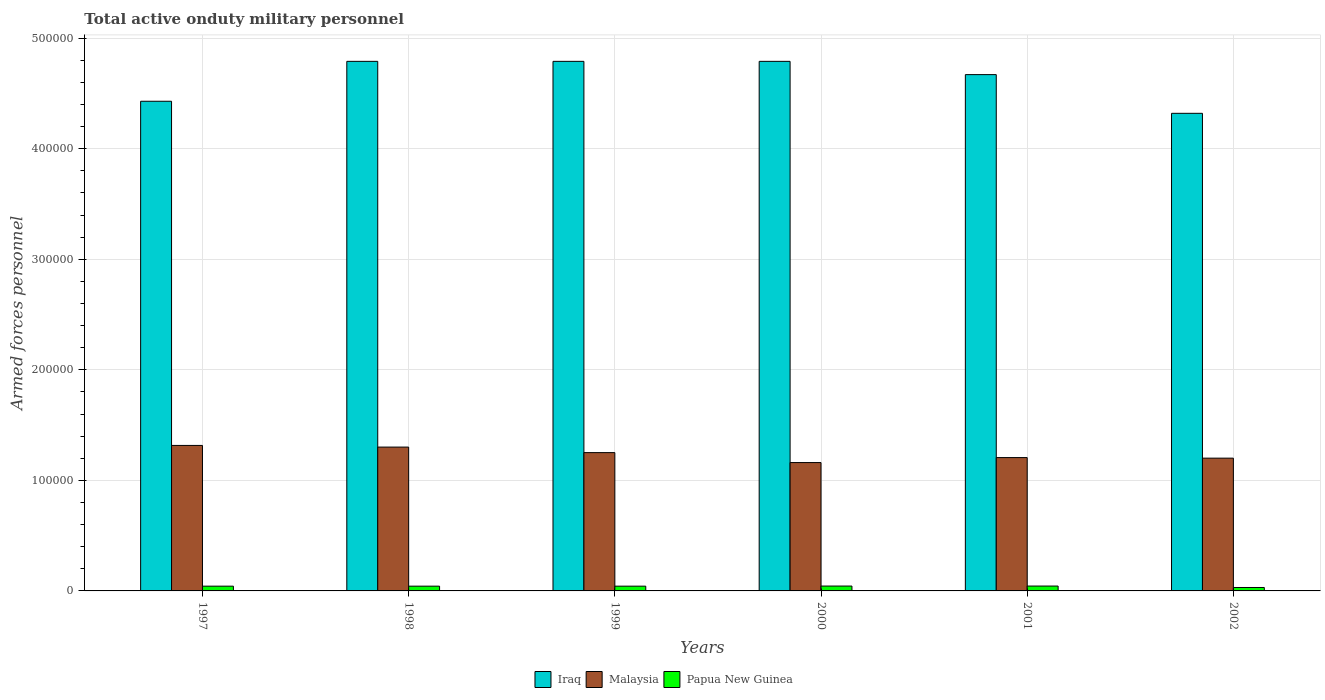How many different coloured bars are there?
Give a very brief answer. 3. Are the number of bars per tick equal to the number of legend labels?
Offer a very short reply. Yes. How many bars are there on the 6th tick from the right?
Offer a terse response. 3. What is the number of armed forces personnel in Papua New Guinea in 2002?
Give a very brief answer. 3100. Across all years, what is the maximum number of armed forces personnel in Papua New Guinea?
Your answer should be very brief. 4400. Across all years, what is the minimum number of armed forces personnel in Papua New Guinea?
Your response must be concise. 3100. What is the total number of armed forces personnel in Papua New Guinea in the graph?
Offer a very short reply. 2.48e+04. What is the difference between the number of armed forces personnel in Malaysia in 2001 and that in 2002?
Keep it short and to the point. 500. What is the difference between the number of armed forces personnel in Iraq in 2000 and the number of armed forces personnel in Papua New Guinea in 1997?
Your answer should be very brief. 4.75e+05. What is the average number of armed forces personnel in Malaysia per year?
Ensure brevity in your answer.  1.24e+05. In the year 1999, what is the difference between the number of armed forces personnel in Malaysia and number of armed forces personnel in Iraq?
Make the answer very short. -3.54e+05. In how many years, is the number of armed forces personnel in Papua New Guinea greater than 40000?
Provide a succinct answer. 0. What is the ratio of the number of armed forces personnel in Iraq in 2001 to that in 2002?
Ensure brevity in your answer.  1.08. Is the number of armed forces personnel in Iraq in 1997 less than that in 1998?
Ensure brevity in your answer.  Yes. What is the difference between the highest and the second highest number of armed forces personnel in Iraq?
Offer a terse response. 0. What is the difference between the highest and the lowest number of armed forces personnel in Papua New Guinea?
Provide a succinct answer. 1300. Is the sum of the number of armed forces personnel in Papua New Guinea in 2000 and 2002 greater than the maximum number of armed forces personnel in Iraq across all years?
Your answer should be compact. No. What does the 1st bar from the left in 1997 represents?
Provide a short and direct response. Iraq. What does the 1st bar from the right in 1997 represents?
Give a very brief answer. Papua New Guinea. Is it the case that in every year, the sum of the number of armed forces personnel in Iraq and number of armed forces personnel in Malaysia is greater than the number of armed forces personnel in Papua New Guinea?
Your answer should be very brief. Yes. How many bars are there?
Keep it short and to the point. 18. Are all the bars in the graph horizontal?
Your response must be concise. No. Where does the legend appear in the graph?
Offer a very short reply. Bottom center. How many legend labels are there?
Your response must be concise. 3. How are the legend labels stacked?
Ensure brevity in your answer.  Horizontal. What is the title of the graph?
Offer a terse response. Total active onduty military personnel. What is the label or title of the X-axis?
Provide a succinct answer. Years. What is the label or title of the Y-axis?
Make the answer very short. Armed forces personnel. What is the Armed forces personnel in Iraq in 1997?
Make the answer very short. 4.43e+05. What is the Armed forces personnel in Malaysia in 1997?
Your answer should be very brief. 1.32e+05. What is the Armed forces personnel of Papua New Guinea in 1997?
Ensure brevity in your answer.  4300. What is the Armed forces personnel in Iraq in 1998?
Make the answer very short. 4.79e+05. What is the Armed forces personnel in Malaysia in 1998?
Your answer should be very brief. 1.30e+05. What is the Armed forces personnel of Papua New Guinea in 1998?
Your response must be concise. 4300. What is the Armed forces personnel in Iraq in 1999?
Your answer should be compact. 4.79e+05. What is the Armed forces personnel in Malaysia in 1999?
Your answer should be very brief. 1.25e+05. What is the Armed forces personnel in Papua New Guinea in 1999?
Give a very brief answer. 4300. What is the Armed forces personnel in Iraq in 2000?
Offer a very short reply. 4.79e+05. What is the Armed forces personnel in Malaysia in 2000?
Keep it short and to the point. 1.16e+05. What is the Armed forces personnel of Papua New Guinea in 2000?
Offer a very short reply. 4400. What is the Armed forces personnel of Iraq in 2001?
Your response must be concise. 4.67e+05. What is the Armed forces personnel in Malaysia in 2001?
Provide a succinct answer. 1.21e+05. What is the Armed forces personnel of Papua New Guinea in 2001?
Ensure brevity in your answer.  4400. What is the Armed forces personnel in Iraq in 2002?
Keep it short and to the point. 4.32e+05. What is the Armed forces personnel of Malaysia in 2002?
Provide a succinct answer. 1.20e+05. What is the Armed forces personnel of Papua New Guinea in 2002?
Offer a very short reply. 3100. Across all years, what is the maximum Armed forces personnel of Iraq?
Your response must be concise. 4.79e+05. Across all years, what is the maximum Armed forces personnel of Malaysia?
Offer a terse response. 1.32e+05. Across all years, what is the maximum Armed forces personnel in Papua New Guinea?
Your answer should be very brief. 4400. Across all years, what is the minimum Armed forces personnel in Iraq?
Your response must be concise. 4.32e+05. Across all years, what is the minimum Armed forces personnel of Malaysia?
Ensure brevity in your answer.  1.16e+05. Across all years, what is the minimum Armed forces personnel in Papua New Guinea?
Offer a very short reply. 3100. What is the total Armed forces personnel of Iraq in the graph?
Your answer should be very brief. 2.78e+06. What is the total Armed forces personnel in Malaysia in the graph?
Your answer should be very brief. 7.44e+05. What is the total Armed forces personnel in Papua New Guinea in the graph?
Make the answer very short. 2.48e+04. What is the difference between the Armed forces personnel in Iraq in 1997 and that in 1998?
Give a very brief answer. -3.61e+04. What is the difference between the Armed forces personnel in Malaysia in 1997 and that in 1998?
Offer a very short reply. 1500. What is the difference between the Armed forces personnel of Papua New Guinea in 1997 and that in 1998?
Ensure brevity in your answer.  0. What is the difference between the Armed forces personnel of Iraq in 1997 and that in 1999?
Ensure brevity in your answer.  -3.61e+04. What is the difference between the Armed forces personnel in Malaysia in 1997 and that in 1999?
Give a very brief answer. 6500. What is the difference between the Armed forces personnel in Papua New Guinea in 1997 and that in 1999?
Provide a succinct answer. 0. What is the difference between the Armed forces personnel of Iraq in 1997 and that in 2000?
Your response must be concise. -3.61e+04. What is the difference between the Armed forces personnel of Malaysia in 1997 and that in 2000?
Give a very brief answer. 1.55e+04. What is the difference between the Armed forces personnel in Papua New Guinea in 1997 and that in 2000?
Your answer should be very brief. -100. What is the difference between the Armed forces personnel of Iraq in 1997 and that in 2001?
Provide a succinct answer. -2.41e+04. What is the difference between the Armed forces personnel of Malaysia in 1997 and that in 2001?
Your answer should be compact. 1.10e+04. What is the difference between the Armed forces personnel of Papua New Guinea in 1997 and that in 2001?
Your answer should be very brief. -100. What is the difference between the Armed forces personnel of Iraq in 1997 and that in 2002?
Your answer should be very brief. 1.09e+04. What is the difference between the Armed forces personnel in Malaysia in 1997 and that in 2002?
Offer a terse response. 1.15e+04. What is the difference between the Armed forces personnel in Papua New Guinea in 1997 and that in 2002?
Keep it short and to the point. 1200. What is the difference between the Armed forces personnel of Malaysia in 1998 and that in 1999?
Your answer should be compact. 5000. What is the difference between the Armed forces personnel in Papua New Guinea in 1998 and that in 1999?
Make the answer very short. 0. What is the difference between the Armed forces personnel of Iraq in 1998 and that in 2000?
Provide a succinct answer. 0. What is the difference between the Armed forces personnel in Malaysia in 1998 and that in 2000?
Give a very brief answer. 1.40e+04. What is the difference between the Armed forces personnel of Papua New Guinea in 1998 and that in 2000?
Make the answer very short. -100. What is the difference between the Armed forces personnel in Iraq in 1998 and that in 2001?
Provide a short and direct response. 1.20e+04. What is the difference between the Armed forces personnel of Malaysia in 1998 and that in 2001?
Your answer should be very brief. 9500. What is the difference between the Armed forces personnel in Papua New Guinea in 1998 and that in 2001?
Provide a succinct answer. -100. What is the difference between the Armed forces personnel in Iraq in 1998 and that in 2002?
Offer a terse response. 4.70e+04. What is the difference between the Armed forces personnel of Malaysia in 1998 and that in 2002?
Give a very brief answer. 10000. What is the difference between the Armed forces personnel of Papua New Guinea in 1998 and that in 2002?
Ensure brevity in your answer.  1200. What is the difference between the Armed forces personnel in Malaysia in 1999 and that in 2000?
Make the answer very short. 9000. What is the difference between the Armed forces personnel of Papua New Guinea in 1999 and that in 2000?
Your answer should be compact. -100. What is the difference between the Armed forces personnel in Iraq in 1999 and that in 2001?
Make the answer very short. 1.20e+04. What is the difference between the Armed forces personnel of Malaysia in 1999 and that in 2001?
Offer a very short reply. 4500. What is the difference between the Armed forces personnel of Papua New Guinea in 1999 and that in 2001?
Your answer should be very brief. -100. What is the difference between the Armed forces personnel of Iraq in 1999 and that in 2002?
Offer a terse response. 4.70e+04. What is the difference between the Armed forces personnel in Papua New Guinea in 1999 and that in 2002?
Your answer should be very brief. 1200. What is the difference between the Armed forces personnel of Iraq in 2000 and that in 2001?
Your answer should be compact. 1.20e+04. What is the difference between the Armed forces personnel in Malaysia in 2000 and that in 2001?
Your response must be concise. -4500. What is the difference between the Armed forces personnel in Iraq in 2000 and that in 2002?
Provide a short and direct response. 4.70e+04. What is the difference between the Armed forces personnel of Malaysia in 2000 and that in 2002?
Ensure brevity in your answer.  -4000. What is the difference between the Armed forces personnel in Papua New Guinea in 2000 and that in 2002?
Your response must be concise. 1300. What is the difference between the Armed forces personnel in Iraq in 2001 and that in 2002?
Keep it short and to the point. 3.50e+04. What is the difference between the Armed forces personnel in Malaysia in 2001 and that in 2002?
Your answer should be very brief. 500. What is the difference between the Armed forces personnel of Papua New Guinea in 2001 and that in 2002?
Provide a succinct answer. 1300. What is the difference between the Armed forces personnel in Iraq in 1997 and the Armed forces personnel in Malaysia in 1998?
Ensure brevity in your answer.  3.13e+05. What is the difference between the Armed forces personnel of Iraq in 1997 and the Armed forces personnel of Papua New Guinea in 1998?
Offer a very short reply. 4.39e+05. What is the difference between the Armed forces personnel of Malaysia in 1997 and the Armed forces personnel of Papua New Guinea in 1998?
Your answer should be compact. 1.27e+05. What is the difference between the Armed forces personnel in Iraq in 1997 and the Armed forces personnel in Malaysia in 1999?
Provide a succinct answer. 3.18e+05. What is the difference between the Armed forces personnel of Iraq in 1997 and the Armed forces personnel of Papua New Guinea in 1999?
Give a very brief answer. 4.39e+05. What is the difference between the Armed forces personnel of Malaysia in 1997 and the Armed forces personnel of Papua New Guinea in 1999?
Ensure brevity in your answer.  1.27e+05. What is the difference between the Armed forces personnel of Iraq in 1997 and the Armed forces personnel of Malaysia in 2000?
Give a very brief answer. 3.27e+05. What is the difference between the Armed forces personnel of Iraq in 1997 and the Armed forces personnel of Papua New Guinea in 2000?
Give a very brief answer. 4.38e+05. What is the difference between the Armed forces personnel in Malaysia in 1997 and the Armed forces personnel in Papua New Guinea in 2000?
Provide a short and direct response. 1.27e+05. What is the difference between the Armed forces personnel of Iraq in 1997 and the Armed forces personnel of Malaysia in 2001?
Your response must be concise. 3.22e+05. What is the difference between the Armed forces personnel of Iraq in 1997 and the Armed forces personnel of Papua New Guinea in 2001?
Keep it short and to the point. 4.38e+05. What is the difference between the Armed forces personnel in Malaysia in 1997 and the Armed forces personnel in Papua New Guinea in 2001?
Ensure brevity in your answer.  1.27e+05. What is the difference between the Armed forces personnel in Iraq in 1997 and the Armed forces personnel in Malaysia in 2002?
Ensure brevity in your answer.  3.23e+05. What is the difference between the Armed forces personnel of Iraq in 1997 and the Armed forces personnel of Papua New Guinea in 2002?
Offer a very short reply. 4.40e+05. What is the difference between the Armed forces personnel in Malaysia in 1997 and the Armed forces personnel in Papua New Guinea in 2002?
Provide a succinct answer. 1.28e+05. What is the difference between the Armed forces personnel in Iraq in 1998 and the Armed forces personnel in Malaysia in 1999?
Provide a succinct answer. 3.54e+05. What is the difference between the Armed forces personnel of Iraq in 1998 and the Armed forces personnel of Papua New Guinea in 1999?
Make the answer very short. 4.75e+05. What is the difference between the Armed forces personnel in Malaysia in 1998 and the Armed forces personnel in Papua New Guinea in 1999?
Make the answer very short. 1.26e+05. What is the difference between the Armed forces personnel of Iraq in 1998 and the Armed forces personnel of Malaysia in 2000?
Give a very brief answer. 3.63e+05. What is the difference between the Armed forces personnel of Iraq in 1998 and the Armed forces personnel of Papua New Guinea in 2000?
Ensure brevity in your answer.  4.75e+05. What is the difference between the Armed forces personnel of Malaysia in 1998 and the Armed forces personnel of Papua New Guinea in 2000?
Provide a succinct answer. 1.26e+05. What is the difference between the Armed forces personnel of Iraq in 1998 and the Armed forces personnel of Malaysia in 2001?
Provide a succinct answer. 3.58e+05. What is the difference between the Armed forces personnel of Iraq in 1998 and the Armed forces personnel of Papua New Guinea in 2001?
Provide a short and direct response. 4.75e+05. What is the difference between the Armed forces personnel in Malaysia in 1998 and the Armed forces personnel in Papua New Guinea in 2001?
Give a very brief answer. 1.26e+05. What is the difference between the Armed forces personnel in Iraq in 1998 and the Armed forces personnel in Malaysia in 2002?
Provide a succinct answer. 3.59e+05. What is the difference between the Armed forces personnel in Iraq in 1998 and the Armed forces personnel in Papua New Guinea in 2002?
Your response must be concise. 4.76e+05. What is the difference between the Armed forces personnel of Malaysia in 1998 and the Armed forces personnel of Papua New Guinea in 2002?
Provide a succinct answer. 1.27e+05. What is the difference between the Armed forces personnel in Iraq in 1999 and the Armed forces personnel in Malaysia in 2000?
Offer a terse response. 3.63e+05. What is the difference between the Armed forces personnel of Iraq in 1999 and the Armed forces personnel of Papua New Guinea in 2000?
Offer a very short reply. 4.75e+05. What is the difference between the Armed forces personnel in Malaysia in 1999 and the Armed forces personnel in Papua New Guinea in 2000?
Your answer should be compact. 1.21e+05. What is the difference between the Armed forces personnel in Iraq in 1999 and the Armed forces personnel in Malaysia in 2001?
Your answer should be very brief. 3.58e+05. What is the difference between the Armed forces personnel of Iraq in 1999 and the Armed forces personnel of Papua New Guinea in 2001?
Make the answer very short. 4.75e+05. What is the difference between the Armed forces personnel in Malaysia in 1999 and the Armed forces personnel in Papua New Guinea in 2001?
Your response must be concise. 1.21e+05. What is the difference between the Armed forces personnel in Iraq in 1999 and the Armed forces personnel in Malaysia in 2002?
Your response must be concise. 3.59e+05. What is the difference between the Armed forces personnel in Iraq in 1999 and the Armed forces personnel in Papua New Guinea in 2002?
Your answer should be compact. 4.76e+05. What is the difference between the Armed forces personnel of Malaysia in 1999 and the Armed forces personnel of Papua New Guinea in 2002?
Your answer should be compact. 1.22e+05. What is the difference between the Armed forces personnel in Iraq in 2000 and the Armed forces personnel in Malaysia in 2001?
Offer a terse response. 3.58e+05. What is the difference between the Armed forces personnel of Iraq in 2000 and the Armed forces personnel of Papua New Guinea in 2001?
Offer a terse response. 4.75e+05. What is the difference between the Armed forces personnel of Malaysia in 2000 and the Armed forces personnel of Papua New Guinea in 2001?
Ensure brevity in your answer.  1.12e+05. What is the difference between the Armed forces personnel in Iraq in 2000 and the Armed forces personnel in Malaysia in 2002?
Give a very brief answer. 3.59e+05. What is the difference between the Armed forces personnel in Iraq in 2000 and the Armed forces personnel in Papua New Guinea in 2002?
Your answer should be very brief. 4.76e+05. What is the difference between the Armed forces personnel in Malaysia in 2000 and the Armed forces personnel in Papua New Guinea in 2002?
Give a very brief answer. 1.13e+05. What is the difference between the Armed forces personnel of Iraq in 2001 and the Armed forces personnel of Malaysia in 2002?
Provide a succinct answer. 3.47e+05. What is the difference between the Armed forces personnel of Iraq in 2001 and the Armed forces personnel of Papua New Guinea in 2002?
Offer a terse response. 4.64e+05. What is the difference between the Armed forces personnel in Malaysia in 2001 and the Armed forces personnel in Papua New Guinea in 2002?
Your answer should be compact. 1.18e+05. What is the average Armed forces personnel in Iraq per year?
Your response must be concise. 4.63e+05. What is the average Armed forces personnel of Malaysia per year?
Ensure brevity in your answer.  1.24e+05. What is the average Armed forces personnel of Papua New Guinea per year?
Offer a very short reply. 4133.33. In the year 1997, what is the difference between the Armed forces personnel of Iraq and Armed forces personnel of Malaysia?
Make the answer very short. 3.11e+05. In the year 1997, what is the difference between the Armed forces personnel of Iraq and Armed forces personnel of Papua New Guinea?
Provide a short and direct response. 4.39e+05. In the year 1997, what is the difference between the Armed forces personnel of Malaysia and Armed forces personnel of Papua New Guinea?
Offer a very short reply. 1.27e+05. In the year 1998, what is the difference between the Armed forces personnel in Iraq and Armed forces personnel in Malaysia?
Give a very brief answer. 3.49e+05. In the year 1998, what is the difference between the Armed forces personnel of Iraq and Armed forces personnel of Papua New Guinea?
Provide a succinct answer. 4.75e+05. In the year 1998, what is the difference between the Armed forces personnel of Malaysia and Armed forces personnel of Papua New Guinea?
Provide a succinct answer. 1.26e+05. In the year 1999, what is the difference between the Armed forces personnel in Iraq and Armed forces personnel in Malaysia?
Give a very brief answer. 3.54e+05. In the year 1999, what is the difference between the Armed forces personnel in Iraq and Armed forces personnel in Papua New Guinea?
Provide a short and direct response. 4.75e+05. In the year 1999, what is the difference between the Armed forces personnel of Malaysia and Armed forces personnel of Papua New Guinea?
Ensure brevity in your answer.  1.21e+05. In the year 2000, what is the difference between the Armed forces personnel of Iraq and Armed forces personnel of Malaysia?
Your answer should be very brief. 3.63e+05. In the year 2000, what is the difference between the Armed forces personnel of Iraq and Armed forces personnel of Papua New Guinea?
Provide a short and direct response. 4.75e+05. In the year 2000, what is the difference between the Armed forces personnel in Malaysia and Armed forces personnel in Papua New Guinea?
Provide a succinct answer. 1.12e+05. In the year 2001, what is the difference between the Armed forces personnel in Iraq and Armed forces personnel in Malaysia?
Make the answer very short. 3.46e+05. In the year 2001, what is the difference between the Armed forces personnel in Iraq and Armed forces personnel in Papua New Guinea?
Offer a very short reply. 4.63e+05. In the year 2001, what is the difference between the Armed forces personnel in Malaysia and Armed forces personnel in Papua New Guinea?
Your answer should be very brief. 1.16e+05. In the year 2002, what is the difference between the Armed forces personnel in Iraq and Armed forces personnel in Malaysia?
Offer a terse response. 3.12e+05. In the year 2002, what is the difference between the Armed forces personnel in Iraq and Armed forces personnel in Papua New Guinea?
Offer a very short reply. 4.29e+05. In the year 2002, what is the difference between the Armed forces personnel of Malaysia and Armed forces personnel of Papua New Guinea?
Keep it short and to the point. 1.17e+05. What is the ratio of the Armed forces personnel in Iraq in 1997 to that in 1998?
Your answer should be compact. 0.92. What is the ratio of the Armed forces personnel in Malaysia in 1997 to that in 1998?
Offer a terse response. 1.01. What is the ratio of the Armed forces personnel of Papua New Guinea in 1997 to that in 1998?
Provide a succinct answer. 1. What is the ratio of the Armed forces personnel of Iraq in 1997 to that in 1999?
Your answer should be compact. 0.92. What is the ratio of the Armed forces personnel in Malaysia in 1997 to that in 1999?
Offer a terse response. 1.05. What is the ratio of the Armed forces personnel of Papua New Guinea in 1997 to that in 1999?
Your answer should be compact. 1. What is the ratio of the Armed forces personnel of Iraq in 1997 to that in 2000?
Your response must be concise. 0.92. What is the ratio of the Armed forces personnel of Malaysia in 1997 to that in 2000?
Provide a succinct answer. 1.13. What is the ratio of the Armed forces personnel of Papua New Guinea in 1997 to that in 2000?
Your answer should be compact. 0.98. What is the ratio of the Armed forces personnel of Iraq in 1997 to that in 2001?
Keep it short and to the point. 0.95. What is the ratio of the Armed forces personnel in Malaysia in 1997 to that in 2001?
Offer a very short reply. 1.09. What is the ratio of the Armed forces personnel in Papua New Guinea in 1997 to that in 2001?
Make the answer very short. 0.98. What is the ratio of the Armed forces personnel of Iraq in 1997 to that in 2002?
Your answer should be compact. 1.03. What is the ratio of the Armed forces personnel in Malaysia in 1997 to that in 2002?
Ensure brevity in your answer.  1.1. What is the ratio of the Armed forces personnel of Papua New Guinea in 1997 to that in 2002?
Keep it short and to the point. 1.39. What is the ratio of the Armed forces personnel in Iraq in 1998 to that in 1999?
Keep it short and to the point. 1. What is the ratio of the Armed forces personnel of Papua New Guinea in 1998 to that in 1999?
Your answer should be very brief. 1. What is the ratio of the Armed forces personnel of Malaysia in 1998 to that in 2000?
Make the answer very short. 1.12. What is the ratio of the Armed forces personnel of Papua New Guinea in 1998 to that in 2000?
Offer a very short reply. 0.98. What is the ratio of the Armed forces personnel in Iraq in 1998 to that in 2001?
Give a very brief answer. 1.03. What is the ratio of the Armed forces personnel in Malaysia in 1998 to that in 2001?
Your answer should be compact. 1.08. What is the ratio of the Armed forces personnel in Papua New Guinea in 1998 to that in 2001?
Your answer should be compact. 0.98. What is the ratio of the Armed forces personnel in Iraq in 1998 to that in 2002?
Your answer should be compact. 1.11. What is the ratio of the Armed forces personnel of Malaysia in 1998 to that in 2002?
Your answer should be compact. 1.08. What is the ratio of the Armed forces personnel of Papua New Guinea in 1998 to that in 2002?
Provide a succinct answer. 1.39. What is the ratio of the Armed forces personnel in Iraq in 1999 to that in 2000?
Offer a terse response. 1. What is the ratio of the Armed forces personnel of Malaysia in 1999 to that in 2000?
Offer a very short reply. 1.08. What is the ratio of the Armed forces personnel of Papua New Guinea in 1999 to that in 2000?
Your answer should be very brief. 0.98. What is the ratio of the Armed forces personnel in Iraq in 1999 to that in 2001?
Make the answer very short. 1.03. What is the ratio of the Armed forces personnel in Malaysia in 1999 to that in 2001?
Provide a succinct answer. 1.04. What is the ratio of the Armed forces personnel in Papua New Guinea in 1999 to that in 2001?
Make the answer very short. 0.98. What is the ratio of the Armed forces personnel of Iraq in 1999 to that in 2002?
Provide a short and direct response. 1.11. What is the ratio of the Armed forces personnel of Malaysia in 1999 to that in 2002?
Your response must be concise. 1.04. What is the ratio of the Armed forces personnel of Papua New Guinea in 1999 to that in 2002?
Offer a terse response. 1.39. What is the ratio of the Armed forces personnel in Iraq in 2000 to that in 2001?
Offer a terse response. 1.03. What is the ratio of the Armed forces personnel in Malaysia in 2000 to that in 2001?
Your response must be concise. 0.96. What is the ratio of the Armed forces personnel of Papua New Guinea in 2000 to that in 2001?
Provide a succinct answer. 1. What is the ratio of the Armed forces personnel in Iraq in 2000 to that in 2002?
Make the answer very short. 1.11. What is the ratio of the Armed forces personnel of Malaysia in 2000 to that in 2002?
Make the answer very short. 0.97. What is the ratio of the Armed forces personnel in Papua New Guinea in 2000 to that in 2002?
Keep it short and to the point. 1.42. What is the ratio of the Armed forces personnel in Iraq in 2001 to that in 2002?
Offer a terse response. 1.08. What is the ratio of the Armed forces personnel in Malaysia in 2001 to that in 2002?
Offer a very short reply. 1. What is the ratio of the Armed forces personnel in Papua New Guinea in 2001 to that in 2002?
Make the answer very short. 1.42. What is the difference between the highest and the second highest Armed forces personnel in Iraq?
Ensure brevity in your answer.  0. What is the difference between the highest and the second highest Armed forces personnel in Malaysia?
Your answer should be compact. 1500. What is the difference between the highest and the second highest Armed forces personnel in Papua New Guinea?
Your answer should be very brief. 0. What is the difference between the highest and the lowest Armed forces personnel of Iraq?
Your answer should be compact. 4.70e+04. What is the difference between the highest and the lowest Armed forces personnel of Malaysia?
Ensure brevity in your answer.  1.55e+04. What is the difference between the highest and the lowest Armed forces personnel in Papua New Guinea?
Offer a terse response. 1300. 